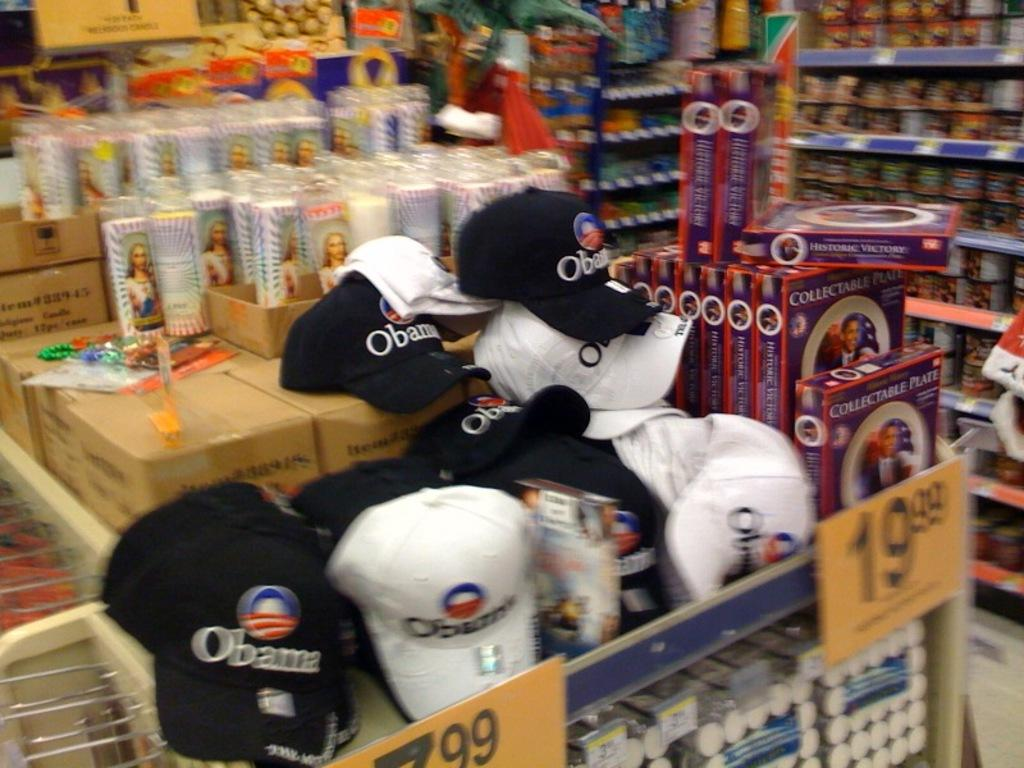<image>
Give a short and clear explanation of the subsequent image. A stack of Obama hats for the upcoming presidential election. 